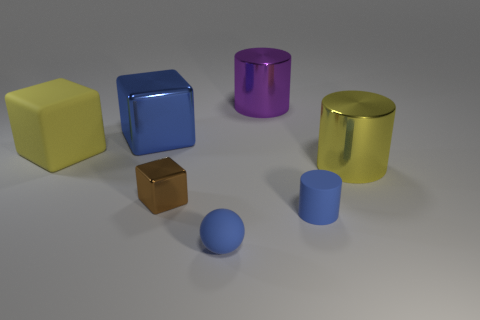Add 1 tiny matte objects. How many objects exist? 8 Subtract all cylinders. How many objects are left? 4 Add 1 big yellow shiny objects. How many big yellow shiny objects are left? 2 Add 2 big brown things. How many big brown things exist? 2 Subtract 0 brown cylinders. How many objects are left? 7 Subtract all big cubes. Subtract all blue matte cylinders. How many objects are left? 4 